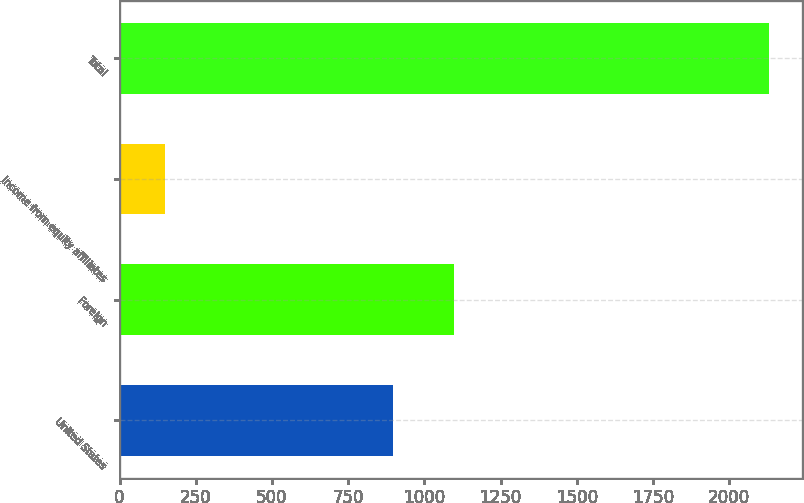<chart> <loc_0><loc_0><loc_500><loc_500><bar_chart><fcel>United States<fcel>Foreign<fcel>Income from equity affiliates<fcel>Total<nl><fcel>897.5<fcel>1095.86<fcel>148.6<fcel>2132.2<nl></chart> 